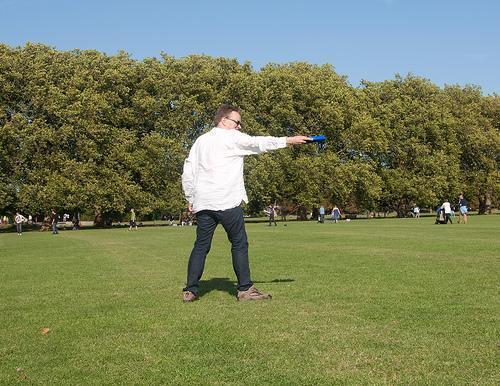How many men are in the front of the picture?
Give a very brief answer. 1. 